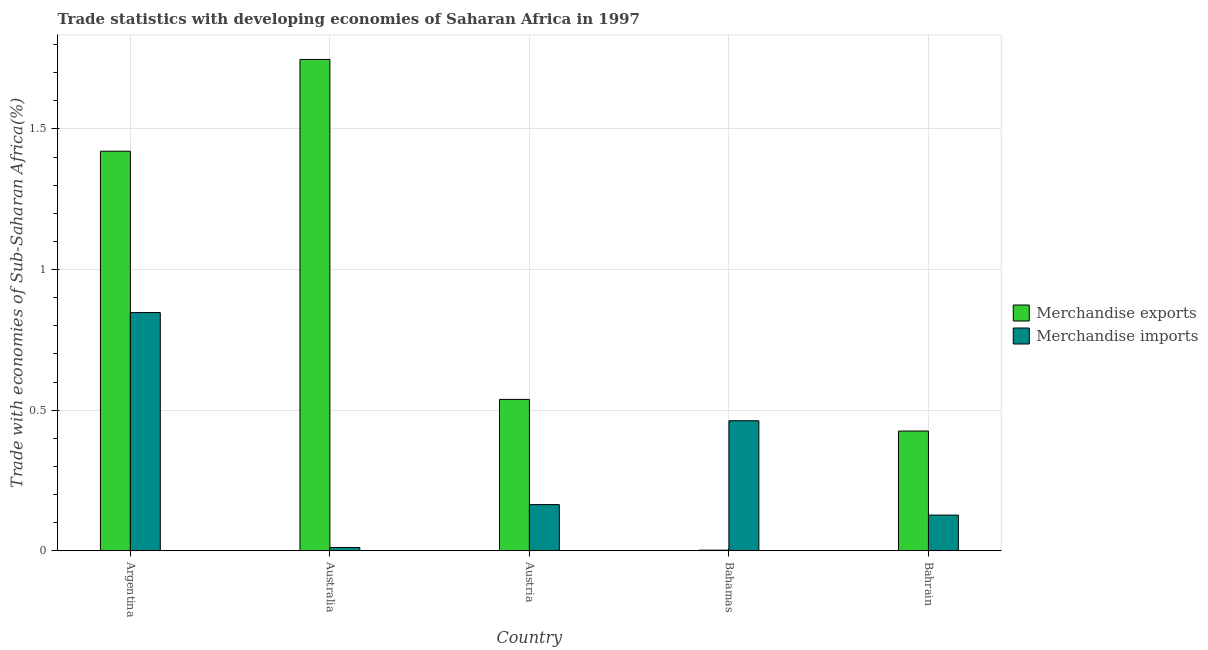How many different coloured bars are there?
Provide a short and direct response. 2. Are the number of bars per tick equal to the number of legend labels?
Offer a very short reply. Yes. How many bars are there on the 1st tick from the left?
Make the answer very short. 2. How many bars are there on the 2nd tick from the right?
Make the answer very short. 2. In how many cases, is the number of bars for a given country not equal to the number of legend labels?
Offer a very short reply. 0. What is the merchandise imports in Australia?
Offer a very short reply. 0.01. Across all countries, what is the maximum merchandise exports?
Your answer should be compact. 1.75. Across all countries, what is the minimum merchandise imports?
Provide a short and direct response. 0.01. In which country was the merchandise exports minimum?
Your response must be concise. Bahamas. What is the total merchandise imports in the graph?
Keep it short and to the point. 1.61. What is the difference between the merchandise imports in Argentina and that in Australia?
Make the answer very short. 0.84. What is the difference between the merchandise imports in Bahamas and the merchandise exports in Bahrain?
Ensure brevity in your answer.  0.04. What is the average merchandise exports per country?
Keep it short and to the point. 0.83. What is the difference between the merchandise exports and merchandise imports in Argentina?
Offer a very short reply. 0.57. In how many countries, is the merchandise imports greater than 0.1 %?
Make the answer very short. 4. What is the ratio of the merchandise exports in Argentina to that in Bahrain?
Offer a terse response. 3.34. Is the merchandise exports in Argentina less than that in Bahrain?
Ensure brevity in your answer.  No. Is the difference between the merchandise imports in Argentina and Bahrain greater than the difference between the merchandise exports in Argentina and Bahrain?
Offer a terse response. No. What is the difference between the highest and the second highest merchandise imports?
Ensure brevity in your answer.  0.38. What is the difference between the highest and the lowest merchandise exports?
Provide a succinct answer. 1.74. In how many countries, is the merchandise exports greater than the average merchandise exports taken over all countries?
Your answer should be very brief. 2. What does the 2nd bar from the right in Argentina represents?
Offer a very short reply. Merchandise exports. How many countries are there in the graph?
Ensure brevity in your answer.  5. What is the difference between two consecutive major ticks on the Y-axis?
Provide a succinct answer. 0.5. Are the values on the major ticks of Y-axis written in scientific E-notation?
Ensure brevity in your answer.  No. Does the graph contain grids?
Provide a short and direct response. Yes. How many legend labels are there?
Offer a very short reply. 2. What is the title of the graph?
Give a very brief answer. Trade statistics with developing economies of Saharan Africa in 1997. Does "Registered firms" appear as one of the legend labels in the graph?
Provide a short and direct response. No. What is the label or title of the X-axis?
Offer a terse response. Country. What is the label or title of the Y-axis?
Offer a very short reply. Trade with economies of Sub-Saharan Africa(%). What is the Trade with economies of Sub-Saharan Africa(%) in Merchandise exports in Argentina?
Keep it short and to the point. 1.42. What is the Trade with economies of Sub-Saharan Africa(%) in Merchandise imports in Argentina?
Provide a succinct answer. 0.85. What is the Trade with economies of Sub-Saharan Africa(%) of Merchandise exports in Australia?
Your answer should be compact. 1.75. What is the Trade with economies of Sub-Saharan Africa(%) of Merchandise imports in Australia?
Offer a terse response. 0.01. What is the Trade with economies of Sub-Saharan Africa(%) of Merchandise exports in Austria?
Ensure brevity in your answer.  0.54. What is the Trade with economies of Sub-Saharan Africa(%) of Merchandise imports in Austria?
Offer a very short reply. 0.16. What is the Trade with economies of Sub-Saharan Africa(%) of Merchandise exports in Bahamas?
Your answer should be compact. 0. What is the Trade with economies of Sub-Saharan Africa(%) in Merchandise imports in Bahamas?
Provide a short and direct response. 0.46. What is the Trade with economies of Sub-Saharan Africa(%) in Merchandise exports in Bahrain?
Your response must be concise. 0.43. What is the Trade with economies of Sub-Saharan Africa(%) of Merchandise imports in Bahrain?
Your response must be concise. 0.13. Across all countries, what is the maximum Trade with economies of Sub-Saharan Africa(%) of Merchandise exports?
Offer a terse response. 1.75. Across all countries, what is the maximum Trade with economies of Sub-Saharan Africa(%) of Merchandise imports?
Your response must be concise. 0.85. Across all countries, what is the minimum Trade with economies of Sub-Saharan Africa(%) of Merchandise exports?
Make the answer very short. 0. Across all countries, what is the minimum Trade with economies of Sub-Saharan Africa(%) of Merchandise imports?
Offer a very short reply. 0.01. What is the total Trade with economies of Sub-Saharan Africa(%) of Merchandise exports in the graph?
Offer a terse response. 4.13. What is the total Trade with economies of Sub-Saharan Africa(%) of Merchandise imports in the graph?
Keep it short and to the point. 1.61. What is the difference between the Trade with economies of Sub-Saharan Africa(%) of Merchandise exports in Argentina and that in Australia?
Provide a short and direct response. -0.33. What is the difference between the Trade with economies of Sub-Saharan Africa(%) in Merchandise imports in Argentina and that in Australia?
Offer a terse response. 0.84. What is the difference between the Trade with economies of Sub-Saharan Africa(%) in Merchandise exports in Argentina and that in Austria?
Provide a short and direct response. 0.88. What is the difference between the Trade with economies of Sub-Saharan Africa(%) of Merchandise imports in Argentina and that in Austria?
Ensure brevity in your answer.  0.68. What is the difference between the Trade with economies of Sub-Saharan Africa(%) of Merchandise exports in Argentina and that in Bahamas?
Give a very brief answer. 1.42. What is the difference between the Trade with economies of Sub-Saharan Africa(%) in Merchandise imports in Argentina and that in Bahamas?
Your answer should be compact. 0.38. What is the difference between the Trade with economies of Sub-Saharan Africa(%) in Merchandise imports in Argentina and that in Bahrain?
Ensure brevity in your answer.  0.72. What is the difference between the Trade with economies of Sub-Saharan Africa(%) of Merchandise exports in Australia and that in Austria?
Your response must be concise. 1.21. What is the difference between the Trade with economies of Sub-Saharan Africa(%) in Merchandise imports in Australia and that in Austria?
Offer a very short reply. -0.15. What is the difference between the Trade with economies of Sub-Saharan Africa(%) of Merchandise exports in Australia and that in Bahamas?
Keep it short and to the point. 1.74. What is the difference between the Trade with economies of Sub-Saharan Africa(%) in Merchandise imports in Australia and that in Bahamas?
Ensure brevity in your answer.  -0.45. What is the difference between the Trade with economies of Sub-Saharan Africa(%) of Merchandise exports in Australia and that in Bahrain?
Offer a very short reply. 1.32. What is the difference between the Trade with economies of Sub-Saharan Africa(%) of Merchandise imports in Australia and that in Bahrain?
Your response must be concise. -0.12. What is the difference between the Trade with economies of Sub-Saharan Africa(%) of Merchandise exports in Austria and that in Bahamas?
Provide a short and direct response. 0.54. What is the difference between the Trade with economies of Sub-Saharan Africa(%) in Merchandise imports in Austria and that in Bahamas?
Provide a short and direct response. -0.3. What is the difference between the Trade with economies of Sub-Saharan Africa(%) in Merchandise exports in Austria and that in Bahrain?
Provide a short and direct response. 0.11. What is the difference between the Trade with economies of Sub-Saharan Africa(%) of Merchandise imports in Austria and that in Bahrain?
Your answer should be very brief. 0.04. What is the difference between the Trade with economies of Sub-Saharan Africa(%) in Merchandise exports in Bahamas and that in Bahrain?
Your answer should be very brief. -0.42. What is the difference between the Trade with economies of Sub-Saharan Africa(%) in Merchandise imports in Bahamas and that in Bahrain?
Offer a very short reply. 0.34. What is the difference between the Trade with economies of Sub-Saharan Africa(%) in Merchandise exports in Argentina and the Trade with economies of Sub-Saharan Africa(%) in Merchandise imports in Australia?
Provide a succinct answer. 1.41. What is the difference between the Trade with economies of Sub-Saharan Africa(%) of Merchandise exports in Argentina and the Trade with economies of Sub-Saharan Africa(%) of Merchandise imports in Austria?
Offer a terse response. 1.26. What is the difference between the Trade with economies of Sub-Saharan Africa(%) of Merchandise exports in Argentina and the Trade with economies of Sub-Saharan Africa(%) of Merchandise imports in Bahamas?
Give a very brief answer. 0.96. What is the difference between the Trade with economies of Sub-Saharan Africa(%) of Merchandise exports in Argentina and the Trade with economies of Sub-Saharan Africa(%) of Merchandise imports in Bahrain?
Your answer should be compact. 1.29. What is the difference between the Trade with economies of Sub-Saharan Africa(%) in Merchandise exports in Australia and the Trade with economies of Sub-Saharan Africa(%) in Merchandise imports in Austria?
Your answer should be compact. 1.58. What is the difference between the Trade with economies of Sub-Saharan Africa(%) in Merchandise exports in Australia and the Trade with economies of Sub-Saharan Africa(%) in Merchandise imports in Bahamas?
Ensure brevity in your answer.  1.28. What is the difference between the Trade with economies of Sub-Saharan Africa(%) of Merchandise exports in Australia and the Trade with economies of Sub-Saharan Africa(%) of Merchandise imports in Bahrain?
Ensure brevity in your answer.  1.62. What is the difference between the Trade with economies of Sub-Saharan Africa(%) of Merchandise exports in Austria and the Trade with economies of Sub-Saharan Africa(%) of Merchandise imports in Bahamas?
Keep it short and to the point. 0.08. What is the difference between the Trade with economies of Sub-Saharan Africa(%) in Merchandise exports in Austria and the Trade with economies of Sub-Saharan Africa(%) in Merchandise imports in Bahrain?
Make the answer very short. 0.41. What is the difference between the Trade with economies of Sub-Saharan Africa(%) of Merchandise exports in Bahamas and the Trade with economies of Sub-Saharan Africa(%) of Merchandise imports in Bahrain?
Ensure brevity in your answer.  -0.12. What is the average Trade with economies of Sub-Saharan Africa(%) in Merchandise exports per country?
Ensure brevity in your answer.  0.83. What is the average Trade with economies of Sub-Saharan Africa(%) in Merchandise imports per country?
Offer a very short reply. 0.32. What is the difference between the Trade with economies of Sub-Saharan Africa(%) in Merchandise exports and Trade with economies of Sub-Saharan Africa(%) in Merchandise imports in Argentina?
Your answer should be compact. 0.57. What is the difference between the Trade with economies of Sub-Saharan Africa(%) of Merchandise exports and Trade with economies of Sub-Saharan Africa(%) of Merchandise imports in Australia?
Give a very brief answer. 1.74. What is the difference between the Trade with economies of Sub-Saharan Africa(%) of Merchandise exports and Trade with economies of Sub-Saharan Africa(%) of Merchandise imports in Austria?
Keep it short and to the point. 0.37. What is the difference between the Trade with economies of Sub-Saharan Africa(%) in Merchandise exports and Trade with economies of Sub-Saharan Africa(%) in Merchandise imports in Bahamas?
Offer a very short reply. -0.46. What is the difference between the Trade with economies of Sub-Saharan Africa(%) of Merchandise exports and Trade with economies of Sub-Saharan Africa(%) of Merchandise imports in Bahrain?
Provide a short and direct response. 0.3. What is the ratio of the Trade with economies of Sub-Saharan Africa(%) in Merchandise exports in Argentina to that in Australia?
Offer a terse response. 0.81. What is the ratio of the Trade with economies of Sub-Saharan Africa(%) in Merchandise imports in Argentina to that in Australia?
Offer a terse response. 72.66. What is the ratio of the Trade with economies of Sub-Saharan Africa(%) in Merchandise exports in Argentina to that in Austria?
Provide a short and direct response. 2.64. What is the ratio of the Trade with economies of Sub-Saharan Africa(%) in Merchandise imports in Argentina to that in Austria?
Keep it short and to the point. 5.16. What is the ratio of the Trade with economies of Sub-Saharan Africa(%) of Merchandise exports in Argentina to that in Bahamas?
Make the answer very short. 644.18. What is the ratio of the Trade with economies of Sub-Saharan Africa(%) in Merchandise imports in Argentina to that in Bahamas?
Give a very brief answer. 1.83. What is the ratio of the Trade with economies of Sub-Saharan Africa(%) in Merchandise exports in Argentina to that in Bahrain?
Your answer should be very brief. 3.34. What is the ratio of the Trade with economies of Sub-Saharan Africa(%) of Merchandise imports in Argentina to that in Bahrain?
Keep it short and to the point. 6.67. What is the ratio of the Trade with economies of Sub-Saharan Africa(%) of Merchandise exports in Australia to that in Austria?
Keep it short and to the point. 3.25. What is the ratio of the Trade with economies of Sub-Saharan Africa(%) of Merchandise imports in Australia to that in Austria?
Make the answer very short. 0.07. What is the ratio of the Trade with economies of Sub-Saharan Africa(%) in Merchandise exports in Australia to that in Bahamas?
Keep it short and to the point. 792.14. What is the ratio of the Trade with economies of Sub-Saharan Africa(%) in Merchandise imports in Australia to that in Bahamas?
Make the answer very short. 0.03. What is the ratio of the Trade with economies of Sub-Saharan Africa(%) of Merchandise exports in Australia to that in Bahrain?
Keep it short and to the point. 4.1. What is the ratio of the Trade with economies of Sub-Saharan Africa(%) of Merchandise imports in Australia to that in Bahrain?
Your response must be concise. 0.09. What is the ratio of the Trade with economies of Sub-Saharan Africa(%) of Merchandise exports in Austria to that in Bahamas?
Provide a succinct answer. 244.02. What is the ratio of the Trade with economies of Sub-Saharan Africa(%) of Merchandise imports in Austria to that in Bahamas?
Offer a terse response. 0.36. What is the ratio of the Trade with economies of Sub-Saharan Africa(%) in Merchandise exports in Austria to that in Bahrain?
Your answer should be very brief. 1.26. What is the ratio of the Trade with economies of Sub-Saharan Africa(%) of Merchandise imports in Austria to that in Bahrain?
Ensure brevity in your answer.  1.29. What is the ratio of the Trade with economies of Sub-Saharan Africa(%) in Merchandise exports in Bahamas to that in Bahrain?
Offer a very short reply. 0.01. What is the ratio of the Trade with economies of Sub-Saharan Africa(%) in Merchandise imports in Bahamas to that in Bahrain?
Make the answer very short. 3.64. What is the difference between the highest and the second highest Trade with economies of Sub-Saharan Africa(%) in Merchandise exports?
Your response must be concise. 0.33. What is the difference between the highest and the second highest Trade with economies of Sub-Saharan Africa(%) in Merchandise imports?
Keep it short and to the point. 0.38. What is the difference between the highest and the lowest Trade with economies of Sub-Saharan Africa(%) of Merchandise exports?
Make the answer very short. 1.74. What is the difference between the highest and the lowest Trade with economies of Sub-Saharan Africa(%) of Merchandise imports?
Give a very brief answer. 0.84. 